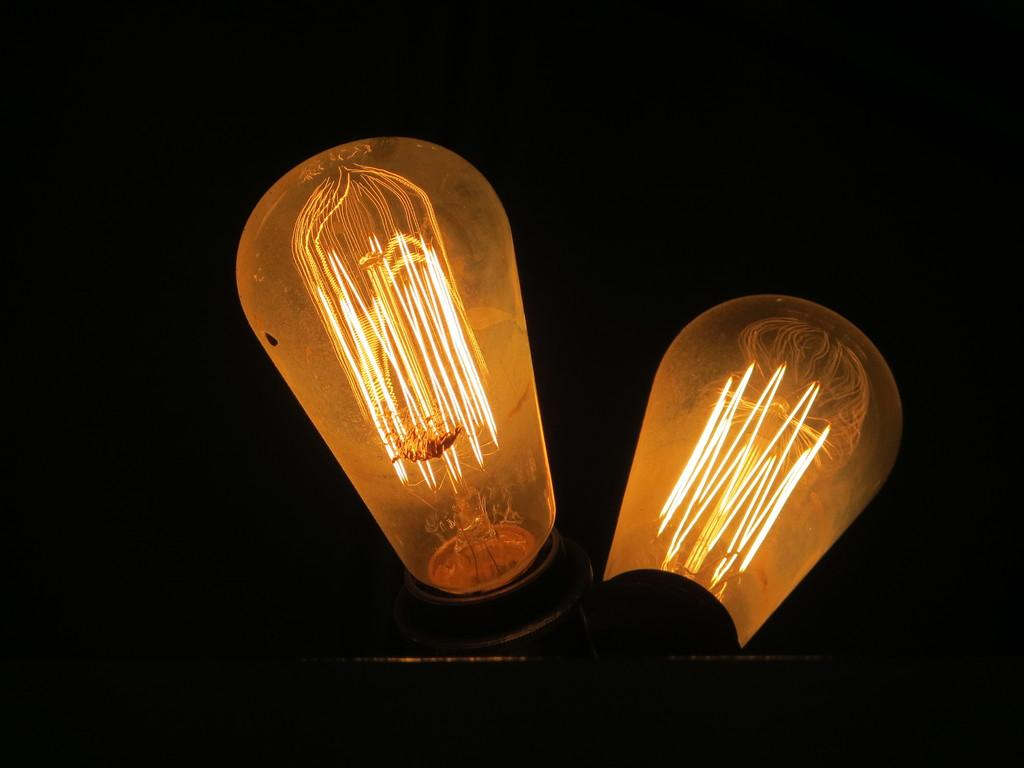What can be seen in the middle of the image? There are two lights in the middle of the image. What is the color of the background in the image? The background of the image is dark in color. What type of food is being served at the event in the image? There is no event or food present in the image; it only features two lights and a dark background. Can you tell me who the guide is in the image? There is no guide present in the image; it only features two lights and a dark background. 